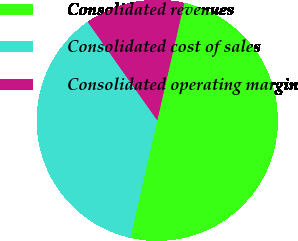<chart> <loc_0><loc_0><loc_500><loc_500><pie_chart><fcel>Consolidated revenues<fcel>Consolidated cost of sales<fcel>Consolidated operating margin<nl><fcel>50.0%<fcel>36.62%<fcel>13.38%<nl></chart> 